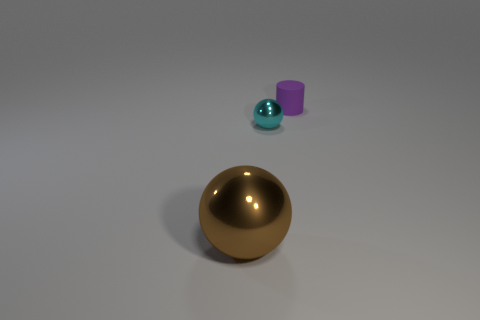There is a purple cylinder; is it the same size as the thing that is to the left of the tiny shiny object?
Give a very brief answer. No. There is a ball that is behind the object on the left side of the small object that is in front of the purple cylinder; what size is it?
Offer a very short reply. Small. Are there any big purple rubber blocks?
Offer a very short reply. No. What number of things are balls to the left of the tiny sphere or objects on the right side of the cyan sphere?
Provide a succinct answer. 2. There is a tiny thing to the right of the small cyan metallic object; how many purple things are behind it?
Make the answer very short. 0. The other small object that is made of the same material as the brown thing is what color?
Provide a short and direct response. Cyan. Is there a object that has the same size as the purple rubber cylinder?
Offer a very short reply. Yes. What shape is the thing that is the same size as the cyan ball?
Offer a very short reply. Cylinder. Are there any other cyan metal things that have the same shape as the big thing?
Provide a short and direct response. Yes. Does the cyan sphere have the same material as the cylinder that is behind the big metal ball?
Make the answer very short. No. 